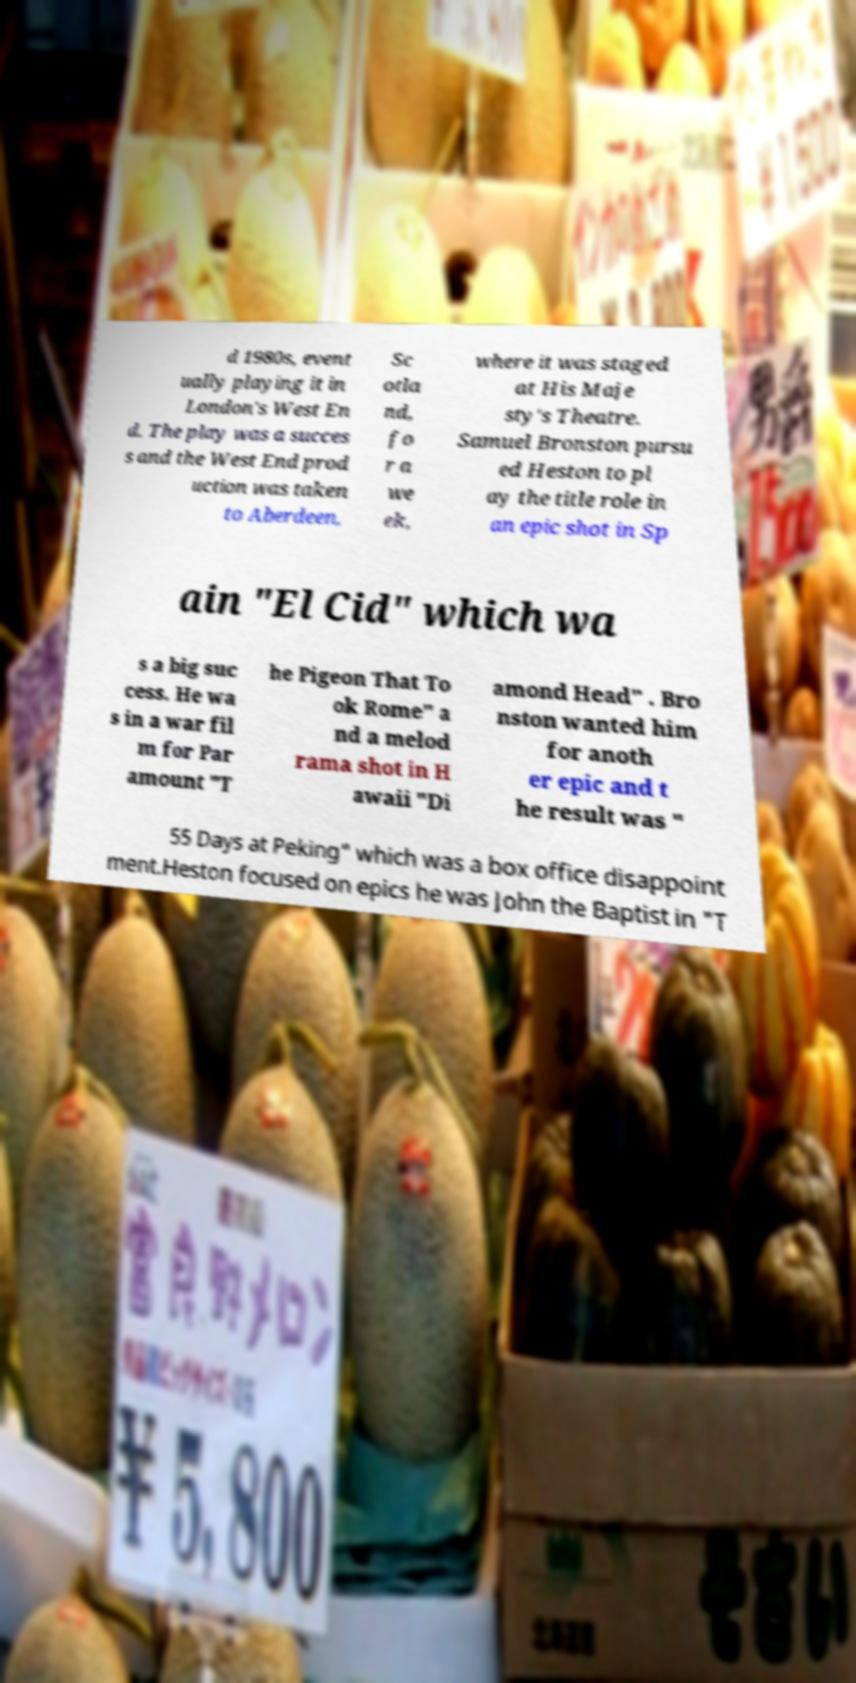Please identify and transcribe the text found in this image. d 1980s, event ually playing it in London's West En d. The play was a succes s and the West End prod uction was taken to Aberdeen, Sc otla nd, fo r a we ek, where it was staged at His Maje sty's Theatre. Samuel Bronston pursu ed Heston to pl ay the title role in an epic shot in Sp ain "El Cid" which wa s a big suc cess. He wa s in a war fil m for Par amount "T he Pigeon That To ok Rome" a nd a melod rama shot in H awaii "Di amond Head" . Bro nston wanted him for anoth er epic and t he result was " 55 Days at Peking" which was a box office disappoint ment.Heston focused on epics he was John the Baptist in "T 